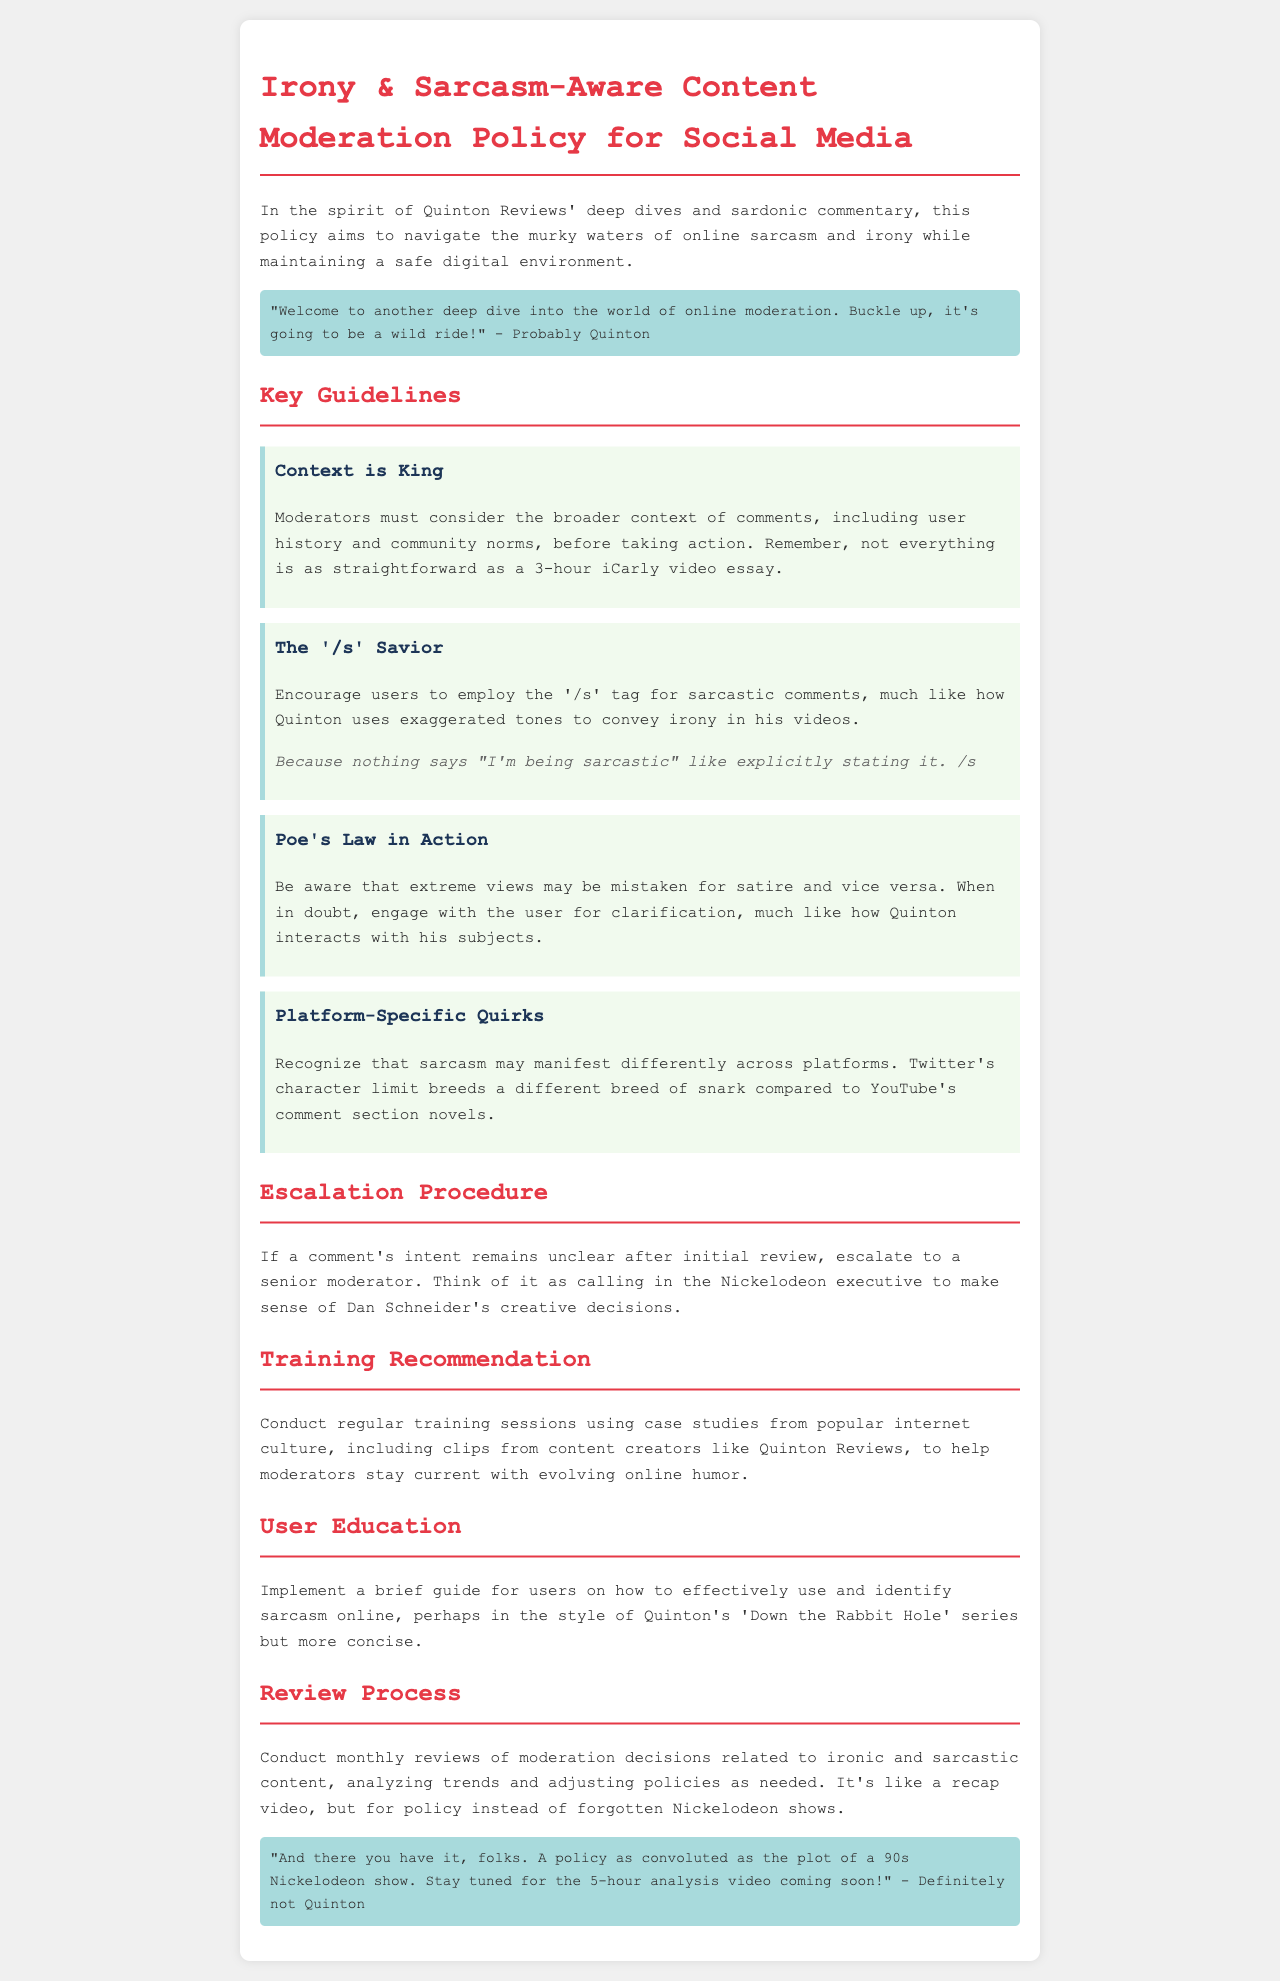What is the title of the document? The title is found at the top of the document in the header section.
Answer: Irony & Sarcasm-Aware Content Moderation Policy for Social Media What should moderators consider before taking action? This information is found in the "Context is King" guideline.
Answer: Broader context What tag is encouraged for sarcastic comments? The specific tag is mentioned in the guideline titled "The '/s' Savior."
Answer: /s What does Poe's Law refer to in this document? The explanation is provided in the guideline about handling extreme views and satire.
Answer: Extreme views may be mistaken for satire How often should moderation decisions be reviewed? This is specified in the "Review Process" section of the document.
Answer: Monthly What is a recommended training method for moderators? This is outlined in the "Training Recommendation" section.
Answer: Case studies from popular internet culture What should users be educated about? This information is presented in the "User Education" section.
Answer: How to effectively use and identify sarcasm What happens if a comment’s intent remains unclear? The escalation process is described in the escalation procedure section.
Answer: Escalate to a senior moderator 